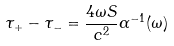<formula> <loc_0><loc_0><loc_500><loc_500>\tau _ { + } - \tau _ { - } = \frac { 4 \omega S } { c ^ { 2 } } \alpha ^ { - 1 } ( \omega )</formula> 